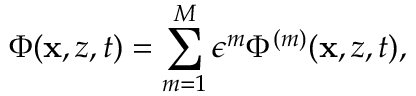Convert formula to latex. <formula><loc_0><loc_0><loc_500><loc_500>\Phi ( x , z , t ) = \sum _ { m = 1 } ^ { M } \epsilon ^ { m } \Phi ^ { ( m ) } ( x , z , t ) ,</formula> 